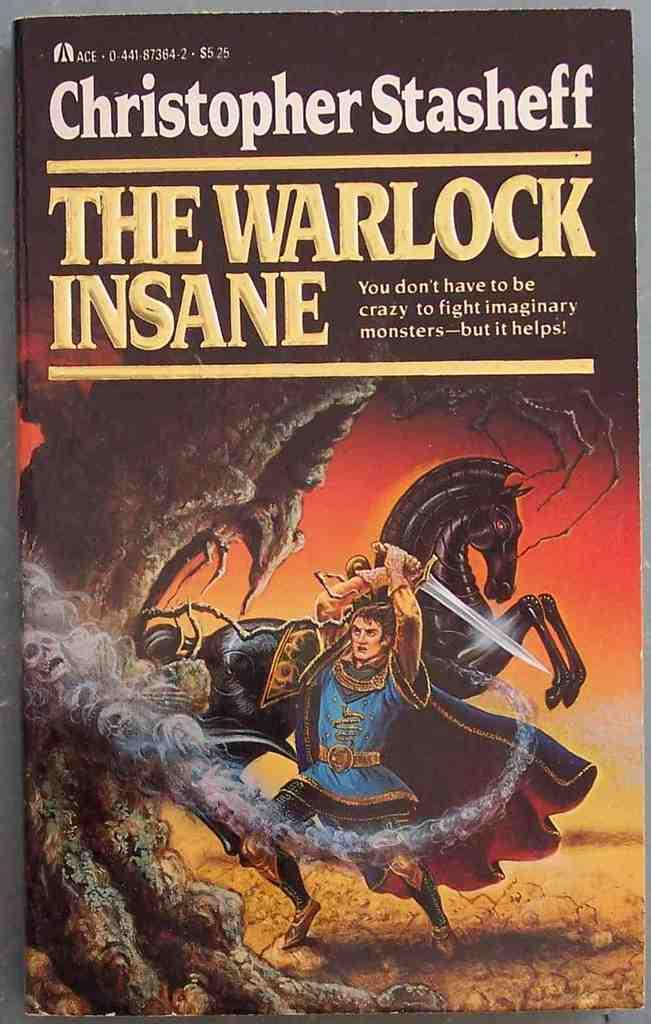<image>
Present a compact description of the photo's key features. A man holds a sword on the cover of "The Warlock Insane" book by Christopher Stasheff. 